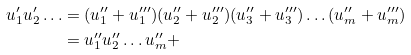Convert formula to latex. <formula><loc_0><loc_0><loc_500><loc_500>u ^ { \prime } _ { 1 } u ^ { \prime } _ { 2 } \dots & = ( u ^ { \prime \prime } _ { 1 } + u _ { 1 } ^ { \prime \prime \prime } ) ( u ^ { \prime \prime } _ { 2 } + u _ { 2 } ^ { \prime \prime \prime } ) ( u _ { 3 } ^ { \prime \prime } + u _ { 3 } ^ { \prime \prime \prime } ) \dots ( u _ { m } ^ { \prime \prime } + u _ { m } ^ { \prime \prime \prime } ) \\ & = u ^ { \prime \prime } _ { 1 } u ^ { \prime \prime } _ { 2 } \dots u _ { m } ^ { \prime \prime } +</formula> 